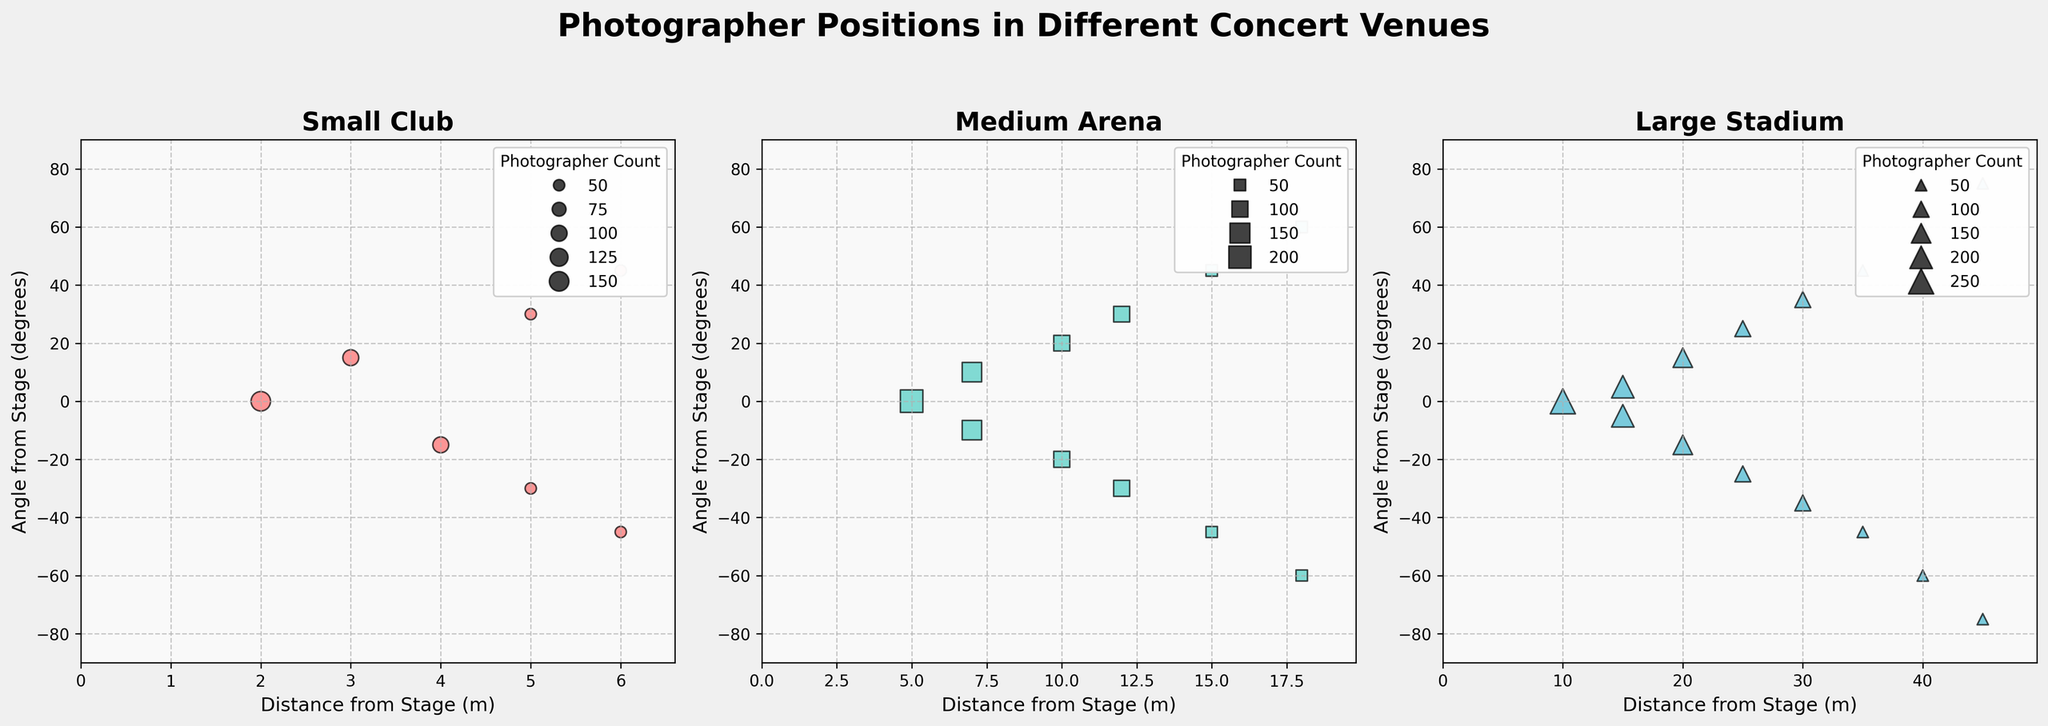What is the maximum distance from the stage captured in the Large Stadium subplot? In the Large Stadium subplot, the points indicating different photographer positions show that the farthest distance from the stage is 45 meters.
Answer: 45 meters How many photographers documented the concert at a 25-degree angle from the stage in the Large Stadium? In the Large Stadium subplot, there are two points at a 25-degree angle, each representing 2 photographers, so the total is 2 + 2 = 4 photographers.
Answer: 4 photographers Comparing the Small Club and Medium Arena, which venue has more photographers positioned directly in line with the stage (0 degrees)? By looking at the subplots, the Small Club has 3 photographers at 0 degrees, while the Medium Arena has 4. Hence, the Medium Arena has more photographers positioned directly in line with the stage.
Answer: Medium Arena What is the average distance from the stage for photographers in the Small Club? The distances for the Small Club are 2, 3, 4, 5, 5, 6, and 6 meters. Adding these values gives a total of 31 meters. Dividing by the number of entries (7), the average distance is 31/7 ≈ 4.43 meters.
Answer: ≈ 4.43 meters At which angle are the most photographers positioned in the Medium Arena? In the Medium Arena subplot, the angles with the largest circle sizes are 10 degrees and -10 degrees, indicating 3 photographers at each of these angles.
Answer: 10 degrees and -10 degrees Which concert venue has the widest distribution of angles where photographers are positioned? By comparing the subplots, the Large Stadium has photographers positioned from -75 to 75 degrees, which is the widest distribution of angles among the venues.
Answer: Large Stadium How many photographers are positioned at an angle greater than or equal to 30 degrees in the Small Club? In the Small Club subplot, there are photographers at 30, -30, 45, and -45 degrees, with counts of 1, 1, 1, and 1 respectively. The total is 1 + 1 + 1 + 1 = 4 photographers.
Answer: 4 photographers In the Medium Arena, what is the combined number of photographers positioned at distances greater than 12 meters from the stage? The distances greater than 12 meters are 15 and 18 meters. At 15 meters, there are 1 + 1 = 2 photographers, and at 18 meters, there is 1 + 1 = 2 photographers. The total is 2 + 2 = 4 photographers.
Answer: 4 photographers 